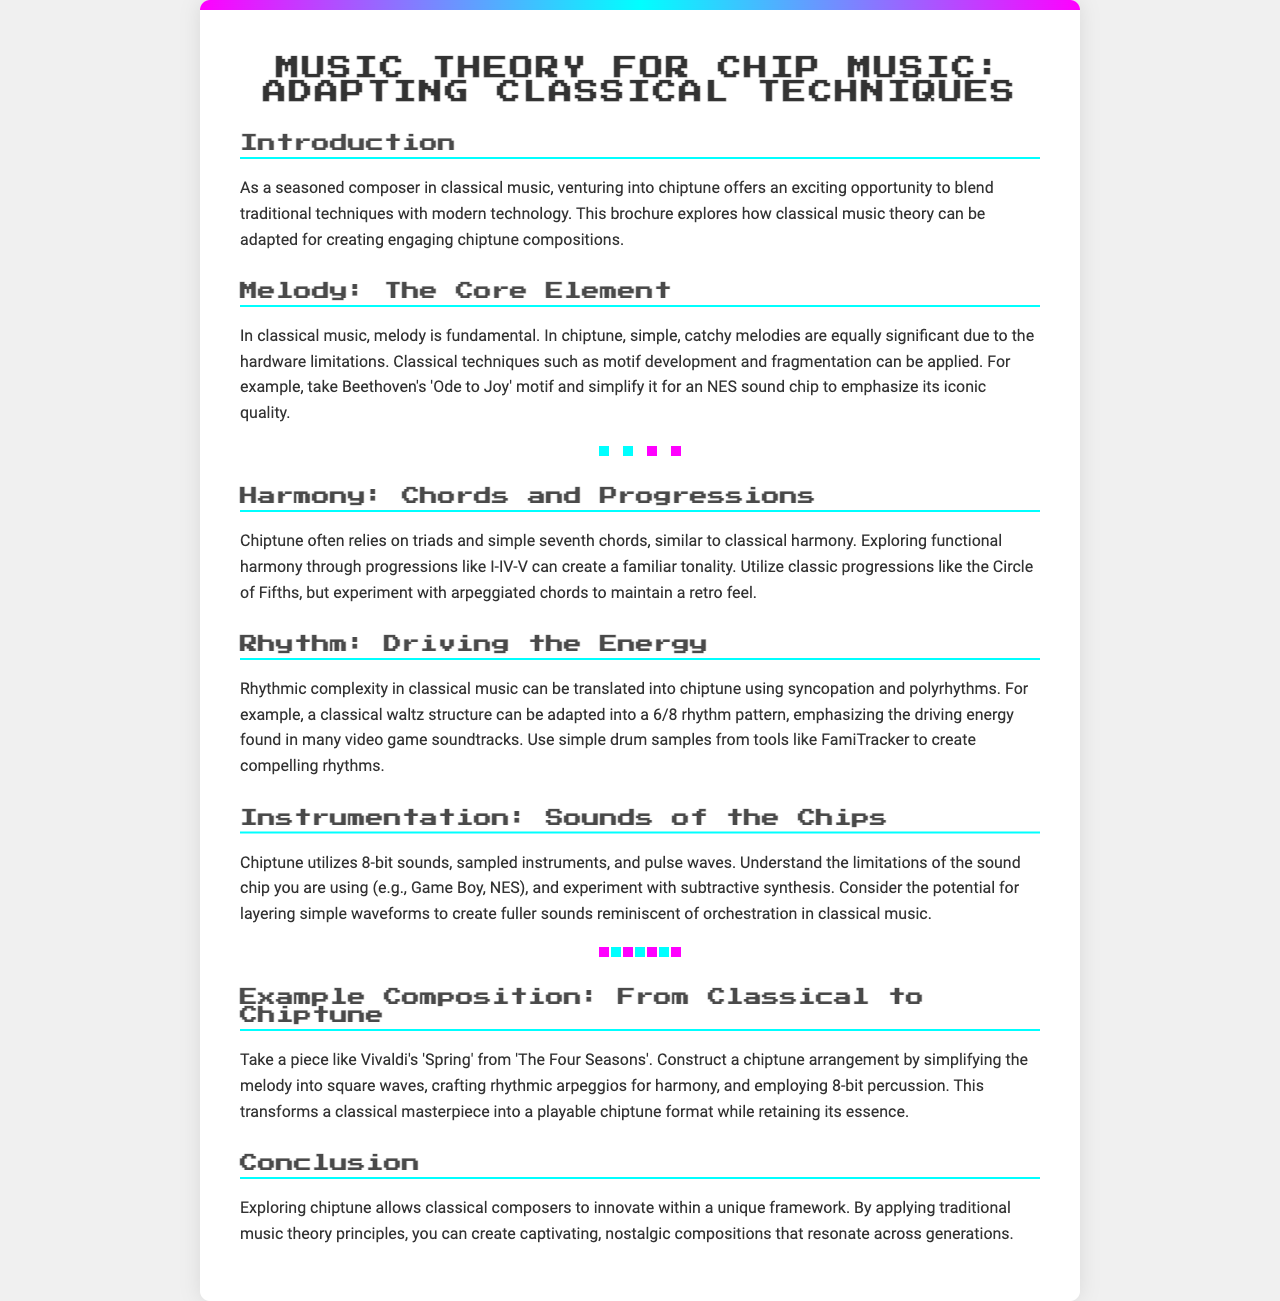What is the title of the brochure? The title is prominently displayed at the top of the brochure.
Answer: Music Theory for Chip Music: Adapting Classical Techniques What genre does the brochure focus on? The brochure discusses a specific music genre that combines elements from classical music with another style.
Answer: Chiptune Which classical composer is mentioned in the melody section? The mention of a significant composer provides context for the classical techniques being discussed.
Answer: Beethoven What rhythmic pattern is suggested for adaptation from classical to chiptune? The adapted rhythm structure is highlighted in the rhythm section as an example of translation from classical elements.
Answer: 6/8 rhythm What type of sounds does chiptune utilize? The instrumentation section describes the types of sounds commonly used in chiptune compositions.
Answer: 8-bit sounds How can traditional progressions be maintained in chiptune? The brochure explains how to retain classical harmonic concepts while using chiptune-specific techniques.
Answer: Arpeggiated chords Which piece is suggested for a chiptune arrangement? An example composition provided illustrates how to transition a classical piece into the chiptune medium.
Answer: Vivaldi's 'Spring' What is emphasized as a core element in both classical and chiptune? The significance of a particular musical aspect is highlighted in the context of both genres.
Answer: Melody 